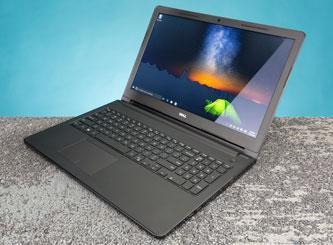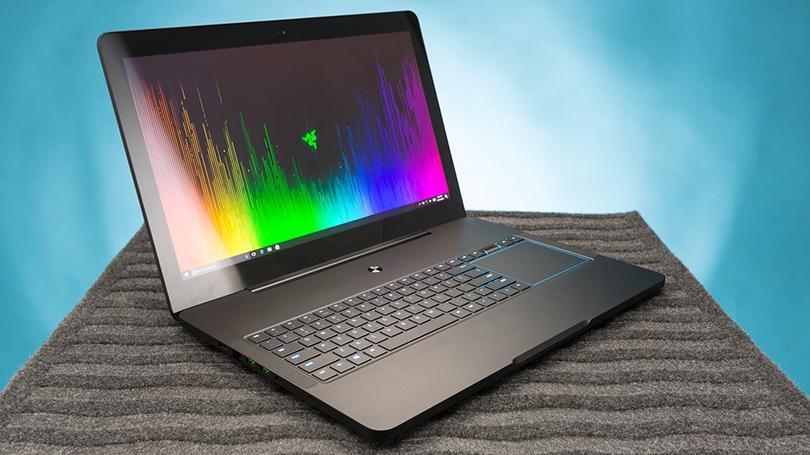The first image is the image on the left, the second image is the image on the right. For the images displayed, is the sentence "there are two laptops in the image, one is open and facing toward the camera, and one facing away" factually correct? Answer yes or no. No. The first image is the image on the left, the second image is the image on the right. Evaluate the accuracy of this statement regarding the images: "One image shows exactly two laptops with one laptop having a blue background on the screen and the other screen not visible, while the other image shows only one laptop with a colorful image on the screen.". Is it true? Answer yes or no. No. 